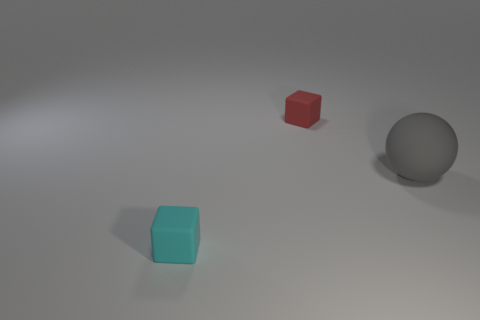Add 1 large blue cubes. How many objects exist? 4 Subtract all cubes. How many objects are left? 1 Subtract all red blocks. Subtract all rubber cubes. How many objects are left? 0 Add 1 tiny cyan things. How many tiny cyan things are left? 2 Add 2 gray balls. How many gray balls exist? 3 Subtract 0 gray blocks. How many objects are left? 3 